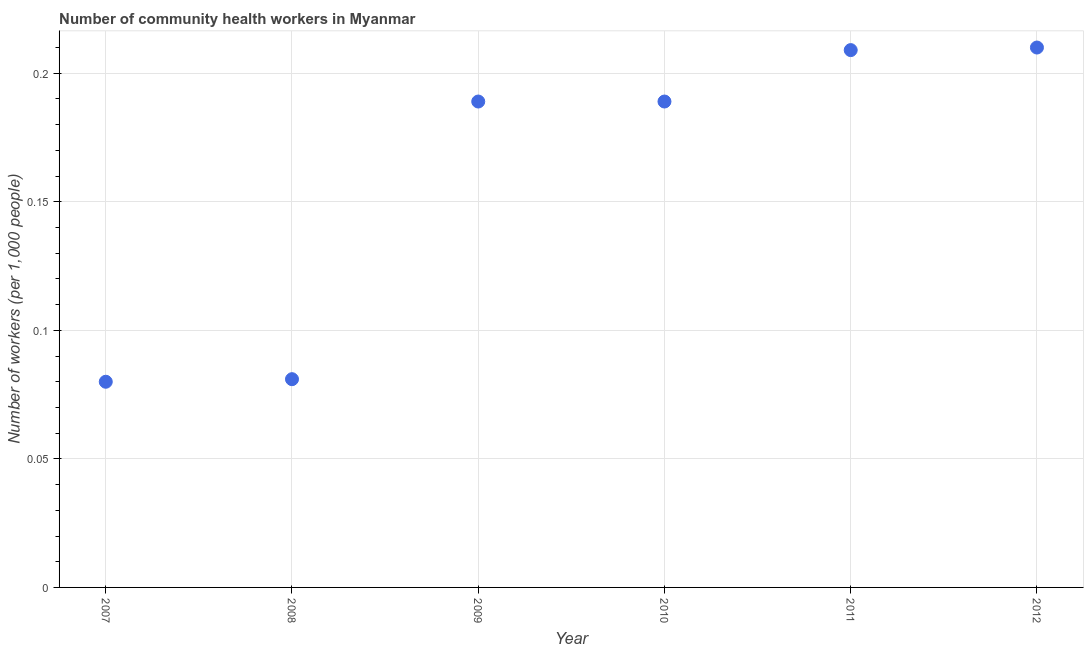What is the number of community health workers in 2008?
Ensure brevity in your answer.  0.08. Across all years, what is the maximum number of community health workers?
Provide a short and direct response. 0.21. What is the sum of the number of community health workers?
Offer a very short reply. 0.96. What is the difference between the number of community health workers in 2009 and 2012?
Your response must be concise. -0.02. What is the average number of community health workers per year?
Provide a short and direct response. 0.16. What is the median number of community health workers?
Offer a very short reply. 0.19. Do a majority of the years between 2009 and 2011 (inclusive) have number of community health workers greater than 0.12000000000000001 ?
Your response must be concise. Yes. What is the ratio of the number of community health workers in 2007 to that in 2010?
Keep it short and to the point. 0.42. Is the number of community health workers in 2009 less than that in 2012?
Provide a succinct answer. Yes. What is the difference between the highest and the second highest number of community health workers?
Offer a very short reply. 0. Is the sum of the number of community health workers in 2009 and 2010 greater than the maximum number of community health workers across all years?
Your answer should be compact. Yes. What is the difference between the highest and the lowest number of community health workers?
Provide a short and direct response. 0.13. In how many years, is the number of community health workers greater than the average number of community health workers taken over all years?
Your response must be concise. 4. How many dotlines are there?
Your answer should be very brief. 1. What is the difference between two consecutive major ticks on the Y-axis?
Make the answer very short. 0.05. Are the values on the major ticks of Y-axis written in scientific E-notation?
Offer a very short reply. No. Does the graph contain any zero values?
Make the answer very short. No. What is the title of the graph?
Your answer should be very brief. Number of community health workers in Myanmar. What is the label or title of the Y-axis?
Make the answer very short. Number of workers (per 1,0 people). What is the Number of workers (per 1,000 people) in 2008?
Provide a short and direct response. 0.08. What is the Number of workers (per 1,000 people) in 2009?
Offer a terse response. 0.19. What is the Number of workers (per 1,000 people) in 2010?
Ensure brevity in your answer.  0.19. What is the Number of workers (per 1,000 people) in 2011?
Make the answer very short. 0.21. What is the Number of workers (per 1,000 people) in 2012?
Make the answer very short. 0.21. What is the difference between the Number of workers (per 1,000 people) in 2007 and 2008?
Provide a short and direct response. -0. What is the difference between the Number of workers (per 1,000 people) in 2007 and 2009?
Your answer should be compact. -0.11. What is the difference between the Number of workers (per 1,000 people) in 2007 and 2010?
Your response must be concise. -0.11. What is the difference between the Number of workers (per 1,000 people) in 2007 and 2011?
Ensure brevity in your answer.  -0.13. What is the difference between the Number of workers (per 1,000 people) in 2007 and 2012?
Your answer should be compact. -0.13. What is the difference between the Number of workers (per 1,000 people) in 2008 and 2009?
Your answer should be very brief. -0.11. What is the difference between the Number of workers (per 1,000 people) in 2008 and 2010?
Your answer should be very brief. -0.11. What is the difference between the Number of workers (per 1,000 people) in 2008 and 2011?
Your response must be concise. -0.13. What is the difference between the Number of workers (per 1,000 people) in 2008 and 2012?
Ensure brevity in your answer.  -0.13. What is the difference between the Number of workers (per 1,000 people) in 2009 and 2010?
Make the answer very short. 0. What is the difference between the Number of workers (per 1,000 people) in 2009 and 2011?
Keep it short and to the point. -0.02. What is the difference between the Number of workers (per 1,000 people) in 2009 and 2012?
Ensure brevity in your answer.  -0.02. What is the difference between the Number of workers (per 1,000 people) in 2010 and 2011?
Give a very brief answer. -0.02. What is the difference between the Number of workers (per 1,000 people) in 2010 and 2012?
Ensure brevity in your answer.  -0.02. What is the difference between the Number of workers (per 1,000 people) in 2011 and 2012?
Provide a succinct answer. -0. What is the ratio of the Number of workers (per 1,000 people) in 2007 to that in 2009?
Your response must be concise. 0.42. What is the ratio of the Number of workers (per 1,000 people) in 2007 to that in 2010?
Provide a short and direct response. 0.42. What is the ratio of the Number of workers (per 1,000 people) in 2007 to that in 2011?
Your response must be concise. 0.38. What is the ratio of the Number of workers (per 1,000 people) in 2007 to that in 2012?
Ensure brevity in your answer.  0.38. What is the ratio of the Number of workers (per 1,000 people) in 2008 to that in 2009?
Keep it short and to the point. 0.43. What is the ratio of the Number of workers (per 1,000 people) in 2008 to that in 2010?
Provide a succinct answer. 0.43. What is the ratio of the Number of workers (per 1,000 people) in 2008 to that in 2011?
Keep it short and to the point. 0.39. What is the ratio of the Number of workers (per 1,000 people) in 2008 to that in 2012?
Your answer should be very brief. 0.39. What is the ratio of the Number of workers (per 1,000 people) in 2009 to that in 2010?
Your response must be concise. 1. What is the ratio of the Number of workers (per 1,000 people) in 2009 to that in 2011?
Keep it short and to the point. 0.9. What is the ratio of the Number of workers (per 1,000 people) in 2009 to that in 2012?
Provide a short and direct response. 0.9. What is the ratio of the Number of workers (per 1,000 people) in 2010 to that in 2011?
Offer a terse response. 0.9. What is the ratio of the Number of workers (per 1,000 people) in 2011 to that in 2012?
Your answer should be compact. 0.99. 